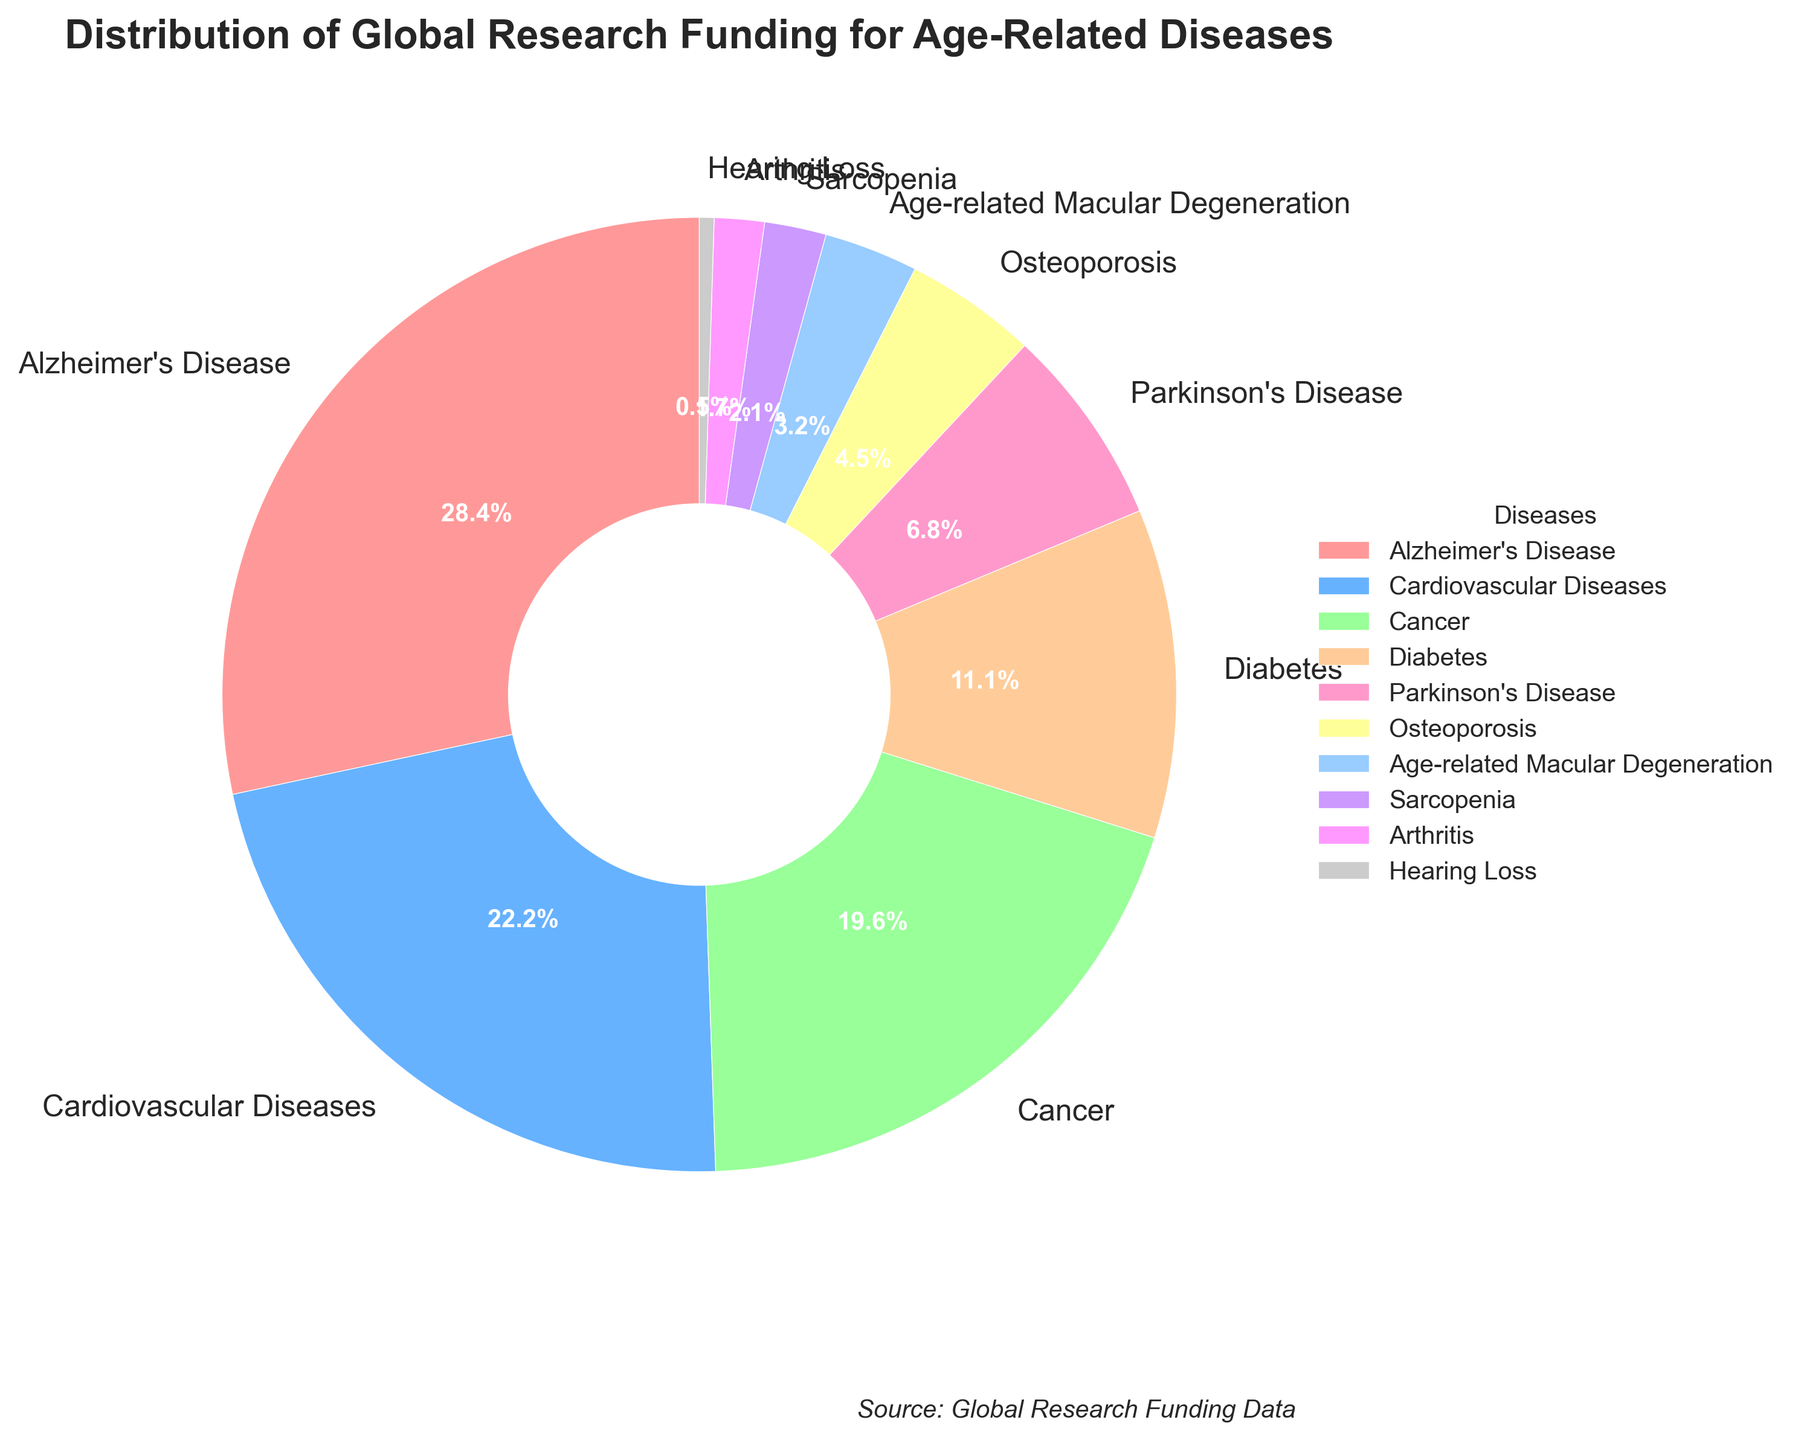Which disease receives the highest percentage of global research funding? The figure's pie chart clearly indicates the portion of research funding awarded to each disease, with Alzheimer's Disease having the largest slice.
Answer: Alzheimer's Disease Which three diseases have the smallest percentage of global research funding? The pie chart visualizes funding distribution, showing that Hearing Loss, Arthritis, and Sarcopenia have the smallest slices.
Answer: Hearing Loss, Arthritis, and Sarcopenia How much more funding does Alzheimer's Disease receive compared to Cardiovascular Diseases? From the chart, we see that Alzheimer's Disease receives 28.5% of the funding while Cardiovascular Diseases receive 22.3%. The difference is calculated as 28.5% - 22.3%.
Answer: 6.2% What is the combined percentage of global research funding for Cancer and Diabetes? Cancer has 19.7% and Diabetes has 11.2%. Adding these together gives us the combined percentage: 19.7% + 11.2%.
Answer: 30.9% Which disease's funding percentage is closest to Parkinson's Disease? Parkinson's Disease receives 6.8% funding. Osteoporosis, listed next to it with 4.5%, is the closest in percentage.
Answer: Osteoporosis Does Age-related Macular Degeneration receive more or less funding than Diabetes? The chart shows Age-related Macular Degeneration at 3.2% and Diabetes at 11.2%. Since 3.2% is less than 11.2%, it receives less funding.
Answer: Less What colors are used for Alzheimer's Disease and Cardiovascular Diseases in the chart? The color for each disease's section of the pie chart is visually distinguishable. Alzheimer's Disease uses a red shade and Cardiovascular Diseases uses a blue shade.
Answer: Red for Alzheimer's Disease, Blue for Cardiovascular Diseases How does the funding for Osteoporosis compare to that for Parkinson's Disease and Diabetes combined? Parkinson's Disease and Diabetes have 6.8% and 11.2% respectively, for a combined 18%. Osteoporosis, with 4.5%, receives less compared to this total.
Answer: Less What is the difference between the funding for Cancer and Cardiovascular Diseases? Cancer has 19.7%, and Cardiovascular Diseases have 22.3%. The difference is simply calculated as 22.3% - 19.7%.
Answer: 2.6% Does Arthritis receive more or less funding than the combination of Hearing Loss and Sarcopenia? Arthritis receives 1.7%. Hearing Loss and Sarcopenia together account for 0.5% + 2.1% = 2.6%. Since 1.7% is less than 2.6%, Arthritis receives less funding.
Answer: Less 